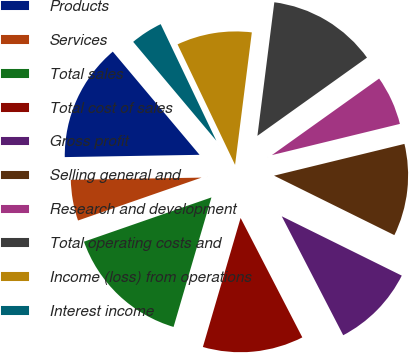Convert chart to OTSL. <chart><loc_0><loc_0><loc_500><loc_500><pie_chart><fcel>Products<fcel>Services<fcel>Total sales<fcel>Total cost of sales<fcel>Gross profit<fcel>Selling general and<fcel>Research and development<fcel>Total operating costs and<fcel>Income (loss) from operations<fcel>Interest income<nl><fcel>14.14%<fcel>5.05%<fcel>15.15%<fcel>12.12%<fcel>10.1%<fcel>11.11%<fcel>6.06%<fcel>13.13%<fcel>9.09%<fcel>4.04%<nl></chart> 